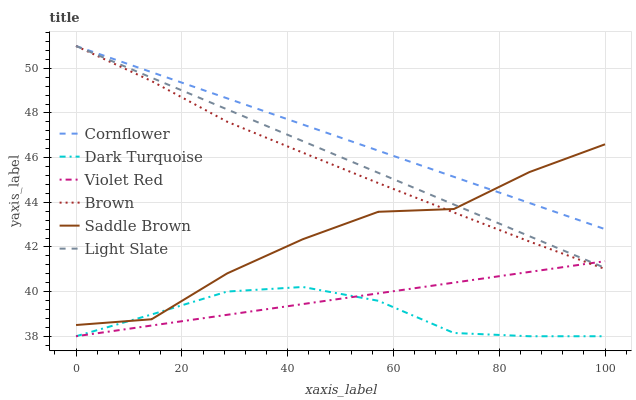Does Dark Turquoise have the minimum area under the curve?
Answer yes or no. Yes. Does Cornflower have the maximum area under the curve?
Answer yes or no. Yes. Does Violet Red have the minimum area under the curve?
Answer yes or no. No. Does Violet Red have the maximum area under the curve?
Answer yes or no. No. Is Violet Red the smoothest?
Answer yes or no. Yes. Is Saddle Brown the roughest?
Answer yes or no. Yes. Is Brown the smoothest?
Answer yes or no. No. Is Brown the roughest?
Answer yes or no. No. Does Violet Red have the lowest value?
Answer yes or no. Yes. Does Brown have the lowest value?
Answer yes or no. No. Does Light Slate have the highest value?
Answer yes or no. Yes. Does Violet Red have the highest value?
Answer yes or no. No. Is Violet Red less than Saddle Brown?
Answer yes or no. Yes. Is Cornflower greater than Dark Turquoise?
Answer yes or no. Yes. Does Dark Turquoise intersect Violet Red?
Answer yes or no. Yes. Is Dark Turquoise less than Violet Red?
Answer yes or no. No. Is Dark Turquoise greater than Violet Red?
Answer yes or no. No. Does Violet Red intersect Saddle Brown?
Answer yes or no. No. 